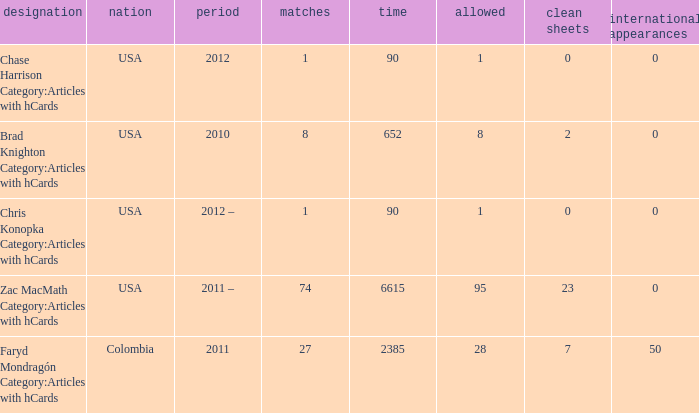When chase harrison category:articles with hcards is the name what is the year? 2012.0. 